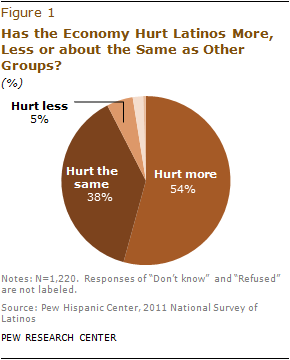Draw attention to some important aspects in this diagram. The perceived value of the opinion "Hurt less" is 0.05. The sum of the median segment and the smallest segment is 0.43. 